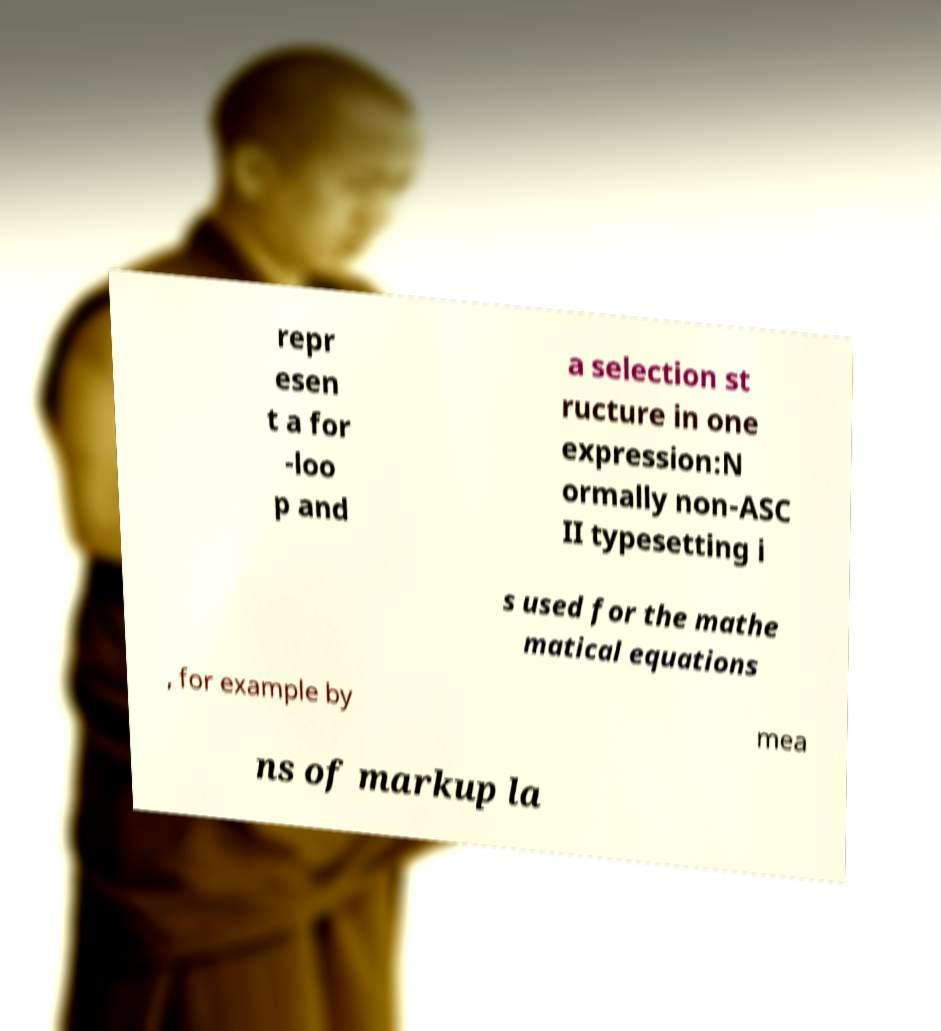Could you extract and type out the text from this image? repr esen t a for -loo p and a selection st ructure in one expression:N ormally non-ASC II typesetting i s used for the mathe matical equations , for example by mea ns of markup la 